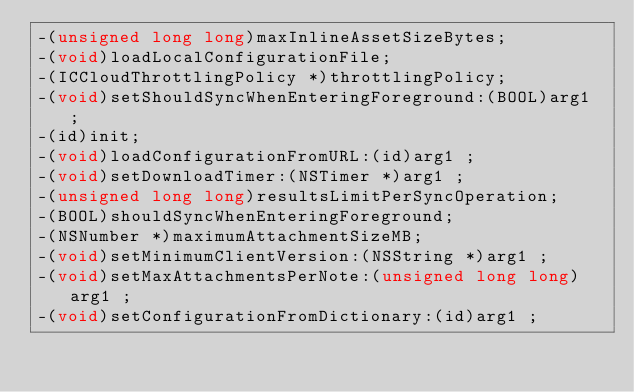Convert code to text. <code><loc_0><loc_0><loc_500><loc_500><_C_>-(unsigned long long)maxInlineAssetSizeBytes;
-(void)loadLocalConfigurationFile;
-(ICCloudThrottlingPolicy *)throttlingPolicy;
-(void)setShouldSyncWhenEnteringForeground:(BOOL)arg1 ;
-(id)init;
-(void)loadConfigurationFromURL:(id)arg1 ;
-(void)setDownloadTimer:(NSTimer *)arg1 ;
-(unsigned long long)resultsLimitPerSyncOperation;
-(BOOL)shouldSyncWhenEnteringForeground;
-(NSNumber *)maximumAttachmentSizeMB;
-(void)setMinimumClientVersion:(NSString *)arg1 ;
-(void)setMaxAttachmentsPerNote:(unsigned long long)arg1 ;
-(void)setConfigurationFromDictionary:(id)arg1 ;</code> 